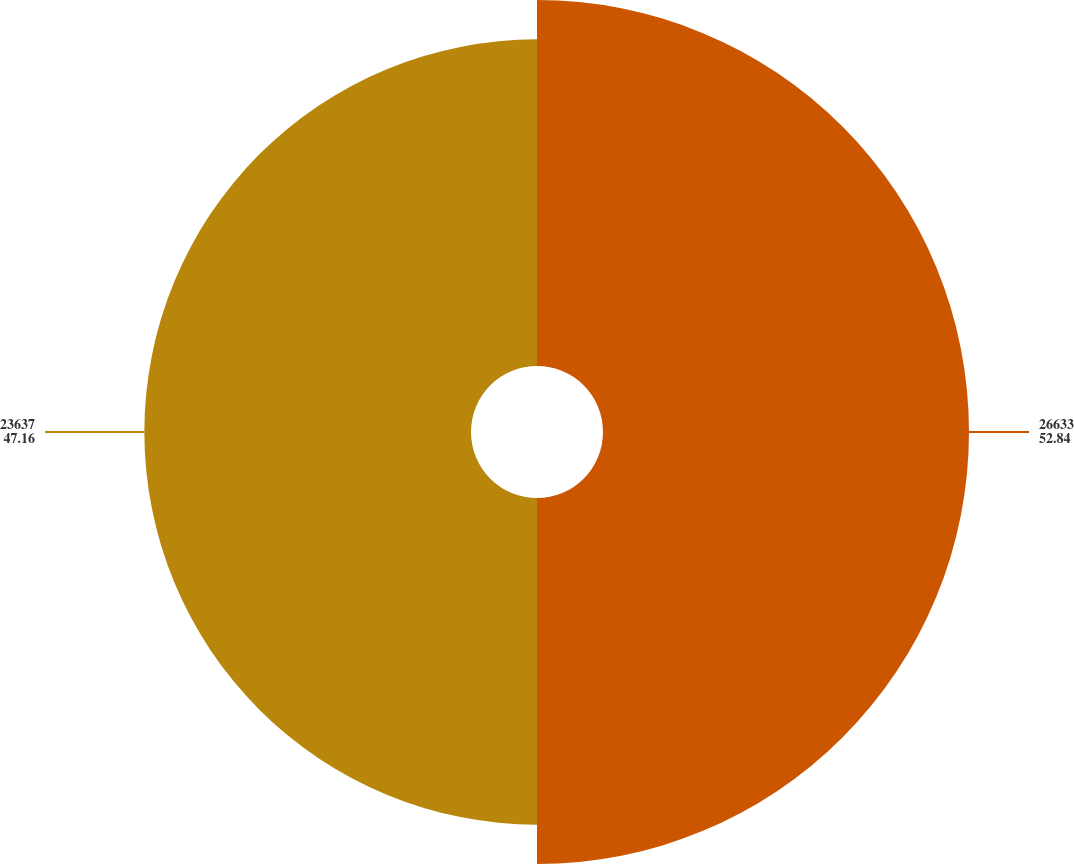Convert chart to OTSL. <chart><loc_0><loc_0><loc_500><loc_500><pie_chart><fcel>26633<fcel>23637<nl><fcel>52.84%<fcel>47.16%<nl></chart> 